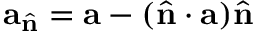Convert formula to latex. <formula><loc_0><loc_0><loc_500><loc_500>a _ { \hat { n } } = a - ( \hat { n } \cdot a ) \hat { n }</formula> 